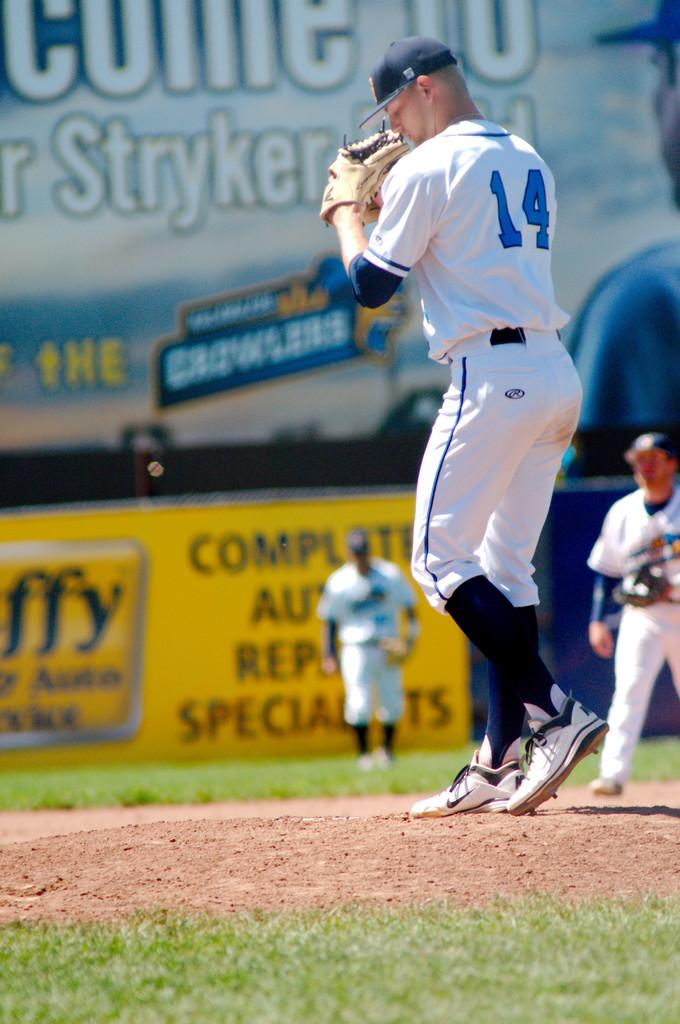<image>
Give a short and clear explanation of the subsequent image. Baseball Pitcher that is preparing to throw a baseball, he is # 14. 